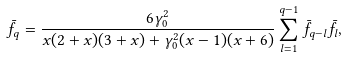<formula> <loc_0><loc_0><loc_500><loc_500>\bar { f } _ { q } = \frac { 6 \gamma ^ { 2 } _ { 0 } } { x ( 2 + x ) ( 3 + x ) + \gamma ^ { 2 } _ { 0 } ( x - 1 ) ( x + 6 ) } \sum ^ { q - 1 } _ { l = 1 } \bar { f } _ { q - l } \bar { f } _ { l } ,</formula> 